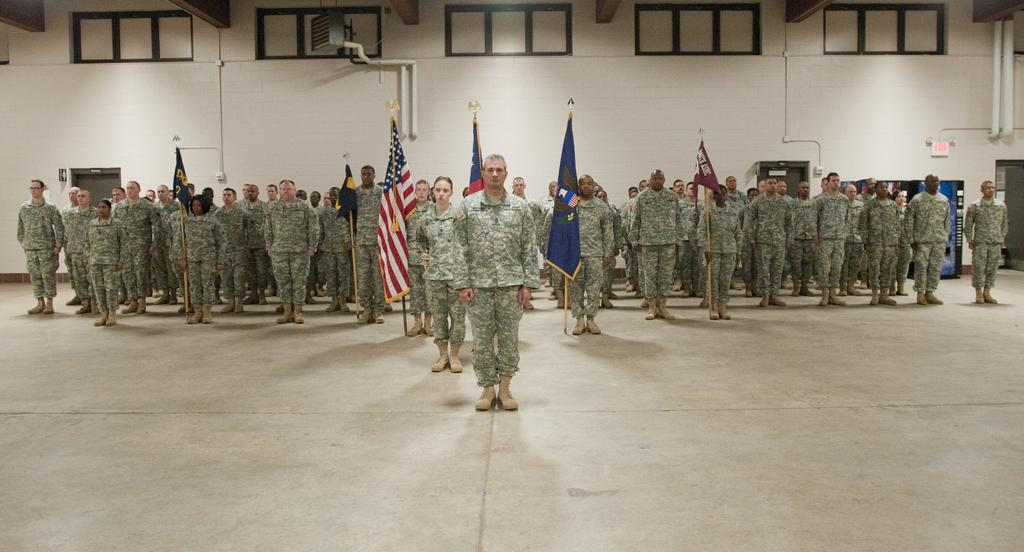What type of clothing are the people wearing in the image? The people are wearing military uniforms in the image. What is the surface that the people are standing on? The people are standing on a surface, but the specific type of surface is not mentioned in the facts. What can be seen in the image besides the people? There are flags, a wall, pipes, doors, and windows in the image. Where is the faucet located in the image? There is no faucet present in the image. What role does the afterthought play in the image? There is no mention of an afterthought in the image or the provided facts. 